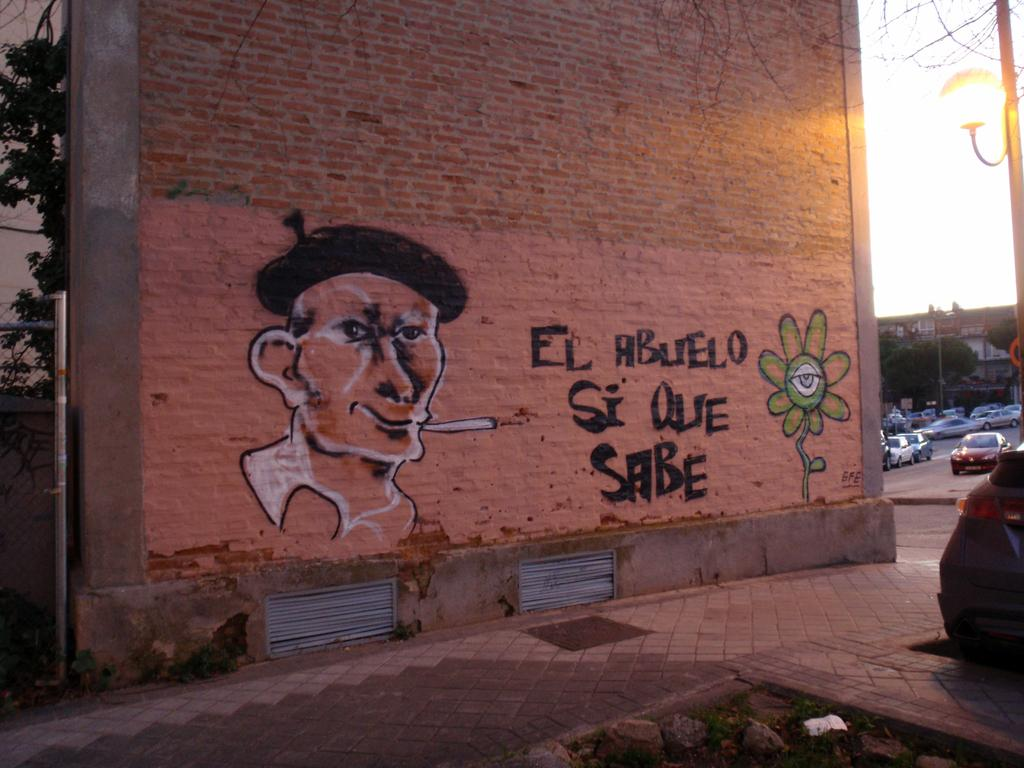What is on the wall in the image? There is a picture on the wall and text on the wall. What can be seen in the parking lot in the image? There are cars in a parking lot. What is located near the cars in the image? There are trees and buildings near the cars. What other object can be seen in the image? There is a lamp post in the image. What type of disease is being discussed in the text on the wall? There is no mention of a disease in the image, as the text on the wall is not related to any medical condition. What selection of breakfast items is available in the image? There is no reference to breakfast or any food items in the image. 